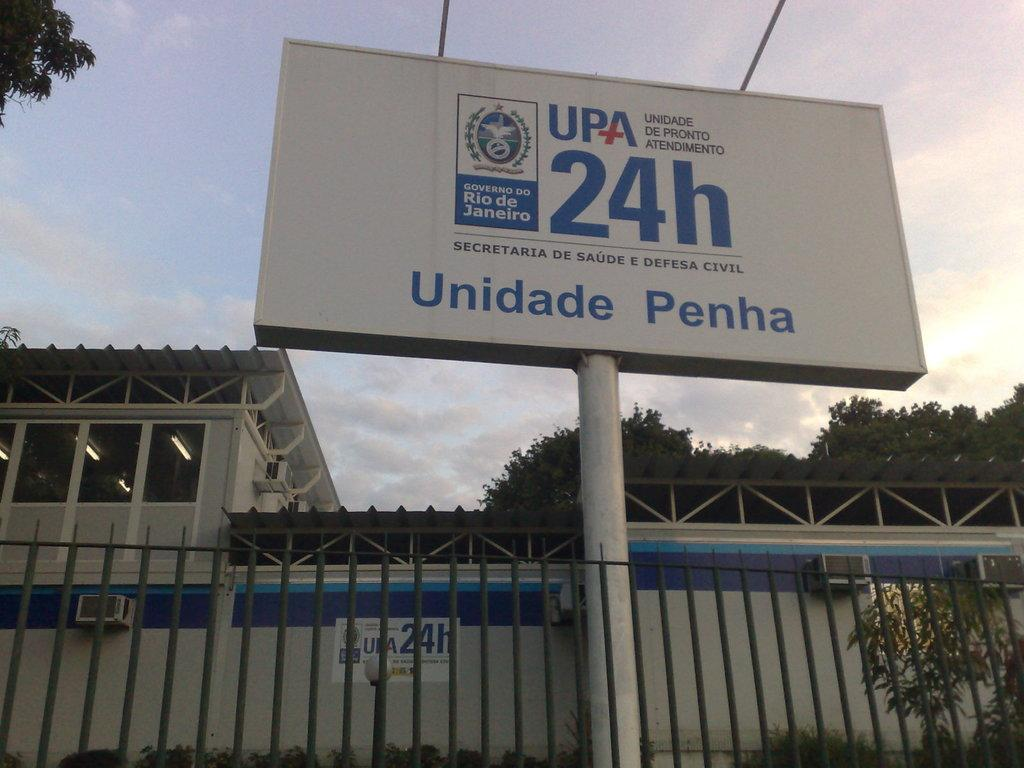<image>
Summarize the visual content of the image. A sign from the Governo do Rio ds Janeiro. 